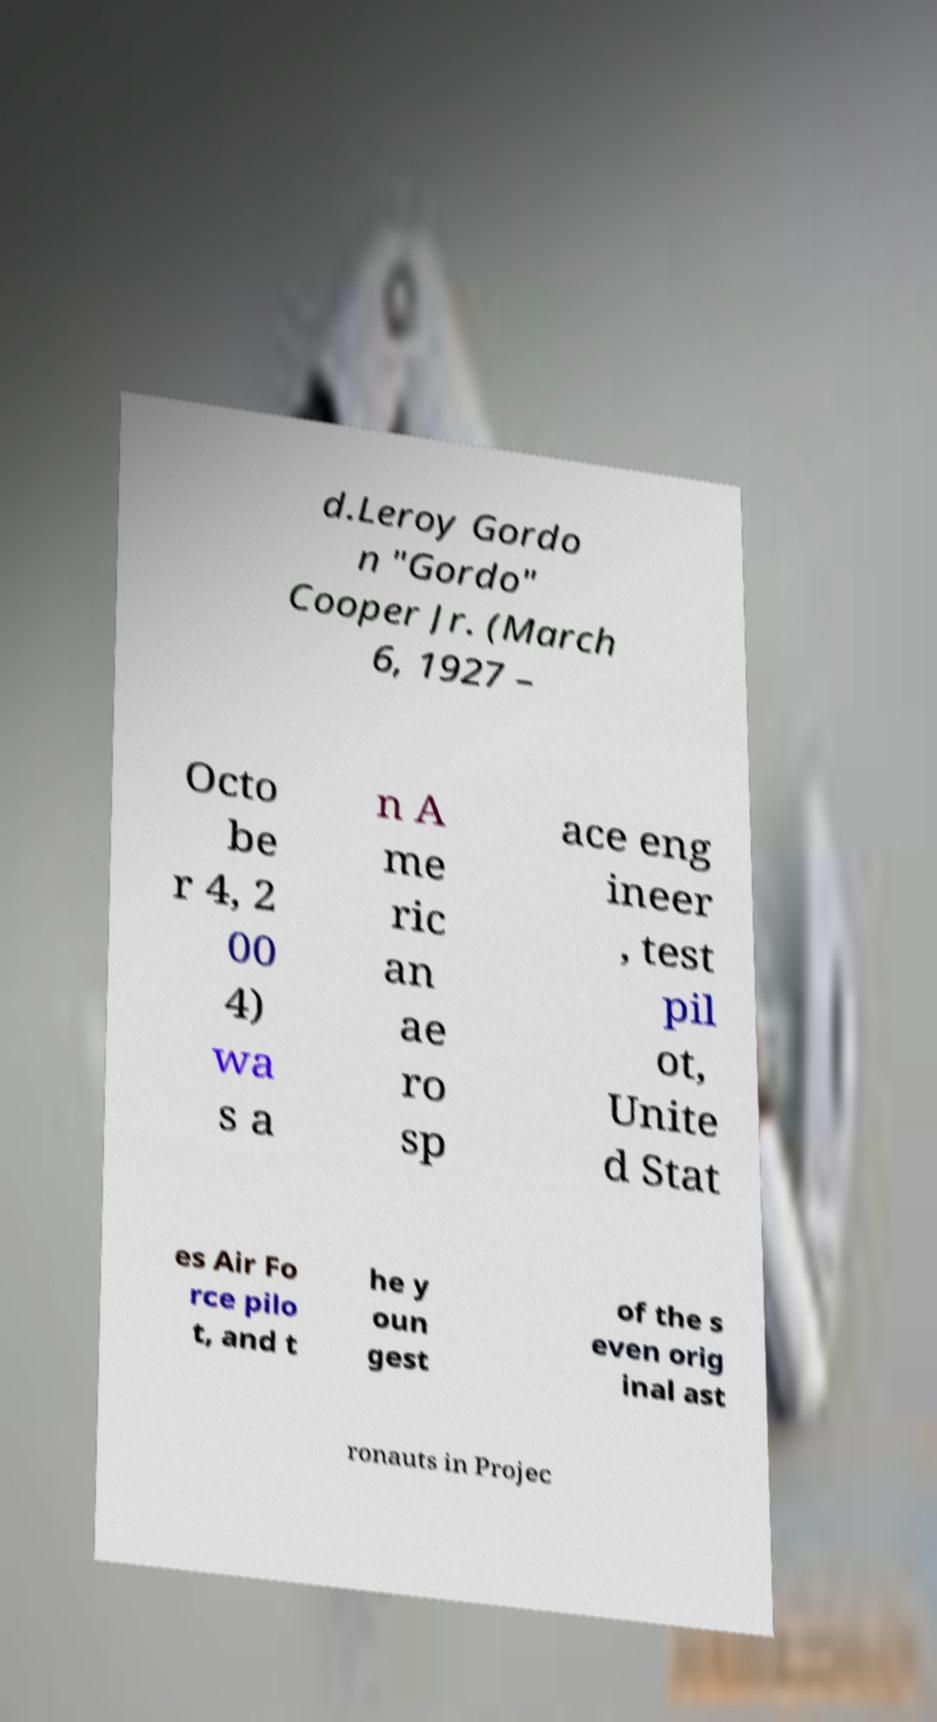Can you read and provide the text displayed in the image?This photo seems to have some interesting text. Can you extract and type it out for me? d.Leroy Gordo n "Gordo" Cooper Jr. (March 6, 1927 – Octo be r 4, 2 00 4) wa s a n A me ric an ae ro sp ace eng ineer , test pil ot, Unite d Stat es Air Fo rce pilo t, and t he y oun gest of the s even orig inal ast ronauts in Projec 